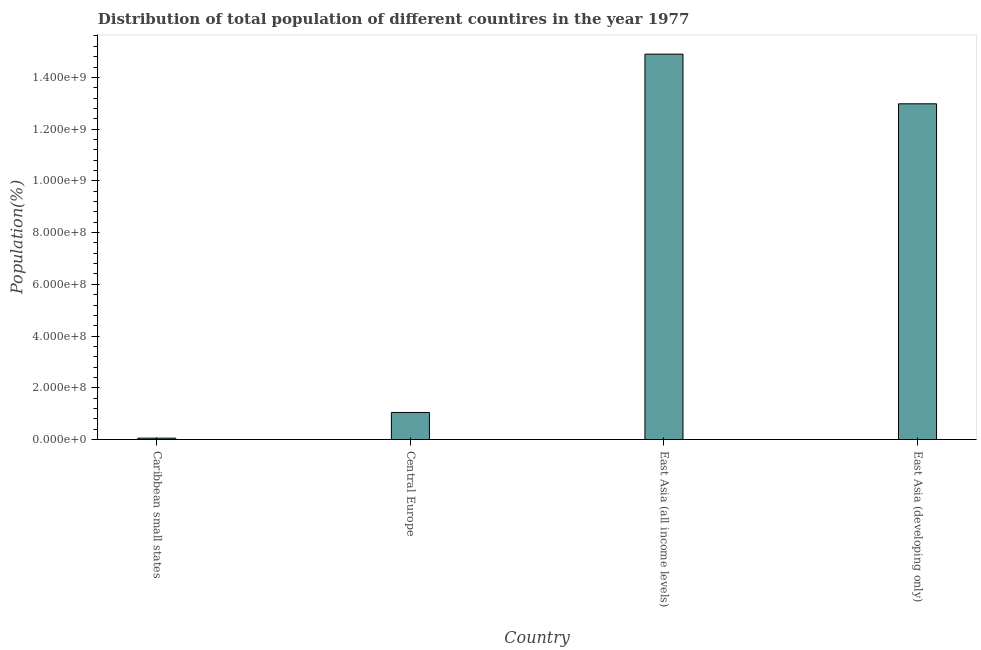Does the graph contain any zero values?
Ensure brevity in your answer.  No. What is the title of the graph?
Ensure brevity in your answer.  Distribution of total population of different countires in the year 1977. What is the label or title of the Y-axis?
Make the answer very short. Population(%). What is the population in Caribbean small states?
Your answer should be compact. 5.29e+06. Across all countries, what is the maximum population?
Ensure brevity in your answer.  1.49e+09. Across all countries, what is the minimum population?
Provide a short and direct response. 5.29e+06. In which country was the population maximum?
Ensure brevity in your answer.  East Asia (all income levels). In which country was the population minimum?
Provide a succinct answer. Caribbean small states. What is the sum of the population?
Offer a very short reply. 2.90e+09. What is the difference between the population in Central Europe and East Asia (all income levels)?
Make the answer very short. -1.39e+09. What is the average population per country?
Give a very brief answer. 7.24e+08. What is the median population?
Offer a terse response. 7.01e+08. What is the ratio of the population in Caribbean small states to that in East Asia (all income levels)?
Provide a succinct answer. 0. What is the difference between the highest and the second highest population?
Keep it short and to the point. 1.92e+08. What is the difference between the highest and the lowest population?
Provide a short and direct response. 1.48e+09. Are all the bars in the graph horizontal?
Your response must be concise. No. What is the Population(%) of Caribbean small states?
Make the answer very short. 5.29e+06. What is the Population(%) of Central Europe?
Ensure brevity in your answer.  1.05e+08. What is the Population(%) of East Asia (all income levels)?
Make the answer very short. 1.49e+09. What is the Population(%) in East Asia (developing only)?
Provide a short and direct response. 1.30e+09. What is the difference between the Population(%) in Caribbean small states and Central Europe?
Give a very brief answer. -9.93e+07. What is the difference between the Population(%) in Caribbean small states and East Asia (all income levels)?
Provide a short and direct response. -1.48e+09. What is the difference between the Population(%) in Caribbean small states and East Asia (developing only)?
Your answer should be very brief. -1.29e+09. What is the difference between the Population(%) in Central Europe and East Asia (all income levels)?
Provide a succinct answer. -1.39e+09. What is the difference between the Population(%) in Central Europe and East Asia (developing only)?
Your answer should be compact. -1.19e+09. What is the difference between the Population(%) in East Asia (all income levels) and East Asia (developing only)?
Offer a terse response. 1.92e+08. What is the ratio of the Population(%) in Caribbean small states to that in Central Europe?
Keep it short and to the point. 0.05. What is the ratio of the Population(%) in Caribbean small states to that in East Asia (all income levels)?
Your answer should be very brief. 0. What is the ratio of the Population(%) in Caribbean small states to that in East Asia (developing only)?
Your answer should be compact. 0. What is the ratio of the Population(%) in Central Europe to that in East Asia (all income levels)?
Your answer should be compact. 0.07. What is the ratio of the Population(%) in Central Europe to that in East Asia (developing only)?
Ensure brevity in your answer.  0.08. What is the ratio of the Population(%) in East Asia (all income levels) to that in East Asia (developing only)?
Your answer should be very brief. 1.15. 